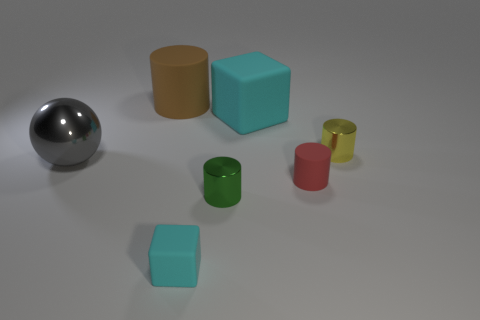Are there the same number of small metal cylinders to the left of the large matte block and spheres?
Make the answer very short. Yes. There is a matte object that is both to the right of the green cylinder and behind the gray ball; what is its shape?
Offer a terse response. Cube. What is the color of the big rubber object that is the same shape as the green metallic thing?
Offer a very short reply. Brown. Is there anything else that has the same color as the metallic ball?
Offer a very short reply. No. There is a matte thing that is in front of the rubber cylinder to the right of the cube behind the small red thing; what is its shape?
Ensure brevity in your answer.  Cube. There is a cyan block that is right of the tiny cube; does it have the same size as the matte cylinder that is in front of the large brown rubber thing?
Offer a terse response. No. What number of big gray spheres are the same material as the red cylinder?
Your answer should be very brief. 0. How many gray metallic objects are on the right side of the tiny red cylinder on the right side of the small shiny object in front of the large gray metallic thing?
Provide a short and direct response. 0. Does the big cyan rubber thing have the same shape as the tiny cyan object?
Your answer should be very brief. Yes. Is there another large brown thing of the same shape as the big brown rubber thing?
Give a very brief answer. No. 